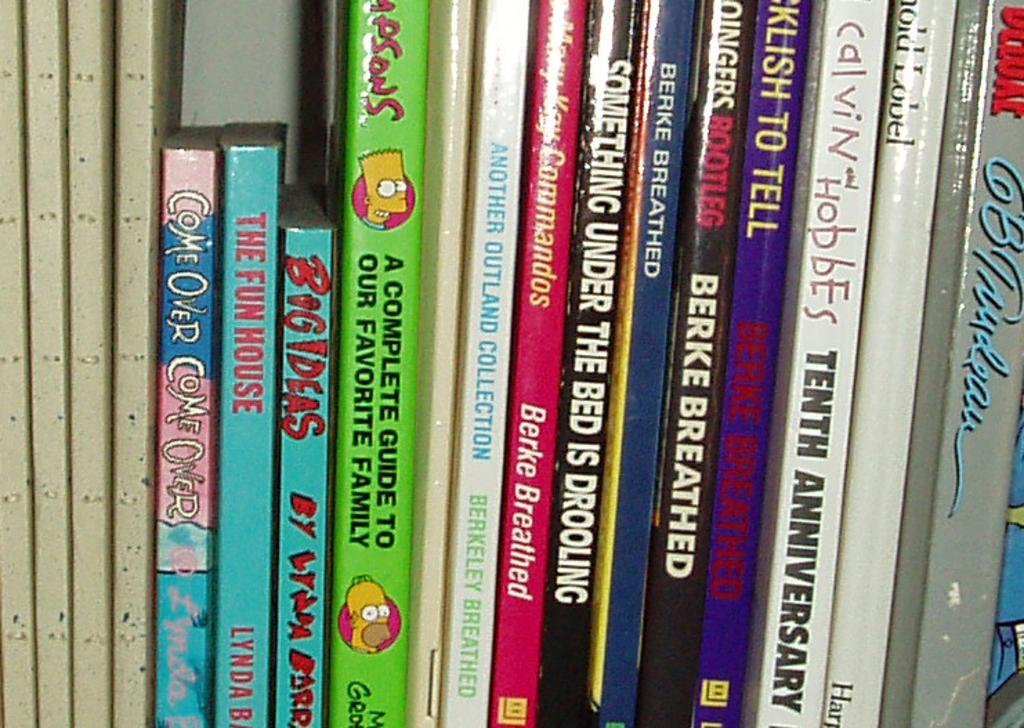<image>
Create a compact narrative representing the image presented. A green book has pictures of Bart and Homer Simpson and is titled A Complete Guide To Our Favorite Family. 